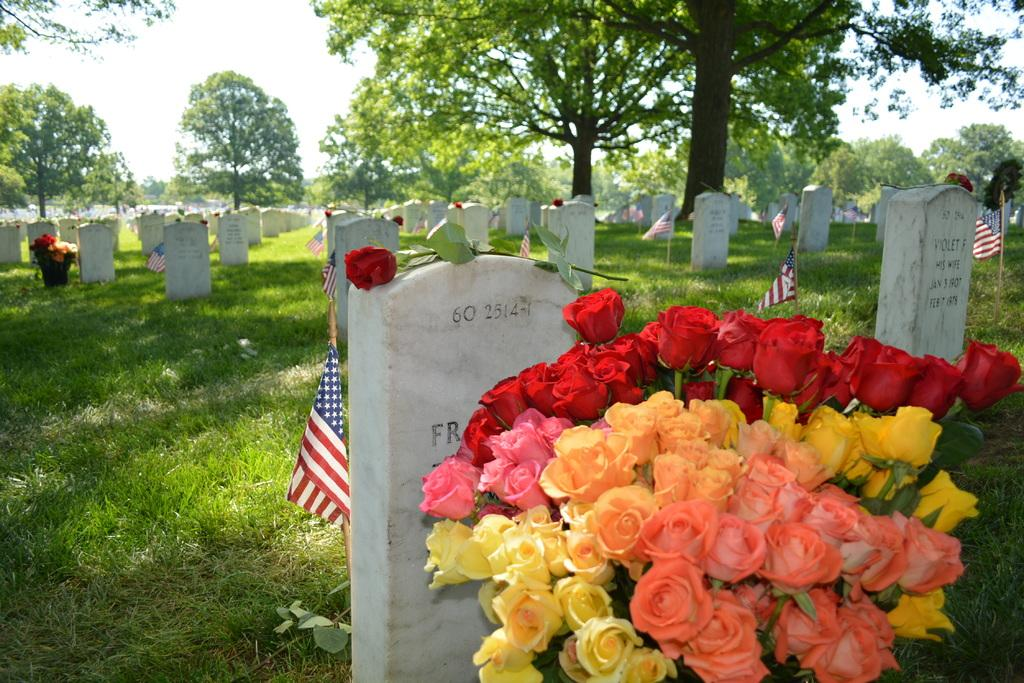What type of flowers can be seen in the image? There are rose flowers in the image. What other objects are present in the image besides the flowers? There are flags and cemeteries in the image. What type of ground cover is visible in the image? There is grass visible in the image. What can be seen in the background of the image? There are trees and the sky visible in the background of the image. What type of vegetable is being harvested in the image? There is no vegetable being harvested in the image; the focus is on rose flowers, flags, cemeteries, grass, trees, and the sky. 